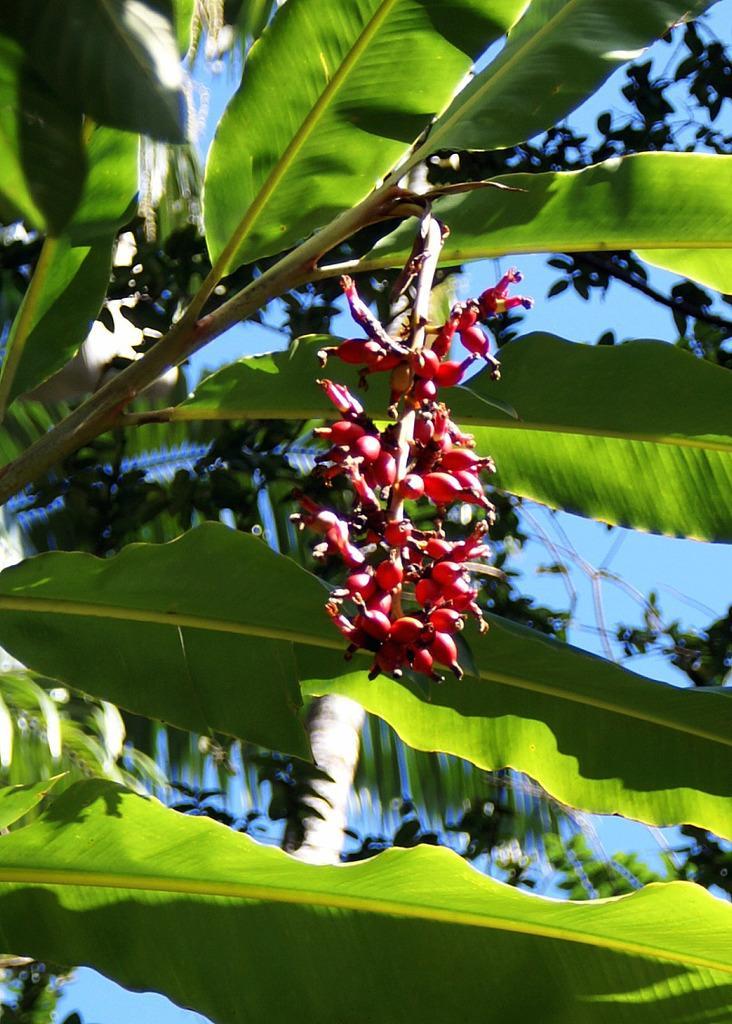Describe this image in one or two sentences. In this image we can see some leaves of a banana tree and there are some fruits which are rd in color and in the background of the image there are some leaves and clear sky. 